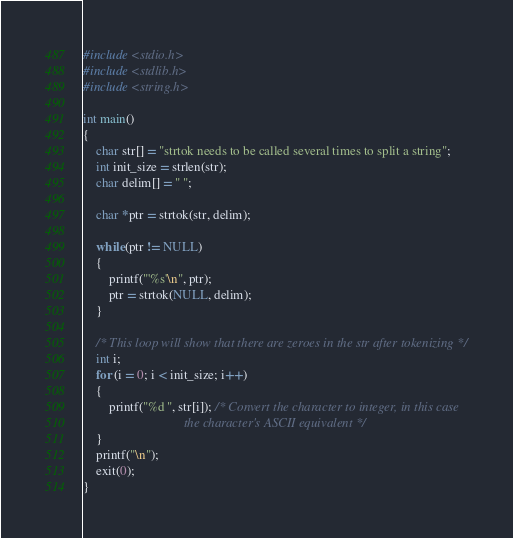Convert code to text. <code><loc_0><loc_0><loc_500><loc_500><_C_>#include <stdio.h>
#include <stdlib.h>
#include <string.h>

int main()
{
	char str[] = "strtok needs to be called several times to split a string";
	int init_size = strlen(str);
	char delim[] = " ";

	char *ptr = strtok(str, delim);

	while(ptr != NULL)
	{
		printf("'%s'\n", ptr);
		ptr = strtok(NULL, delim);
	}

	/* This loop will show that there are zeroes in the str after tokenizing */
	int i;
	for (i = 0; i < init_size; i++)
	{
		printf("%d ", str[i]); /* Convert the character to integer, in this case
							   the character's ASCII equivalent */
	}
	printf("\n");
	exit(0);
}	

</code> 